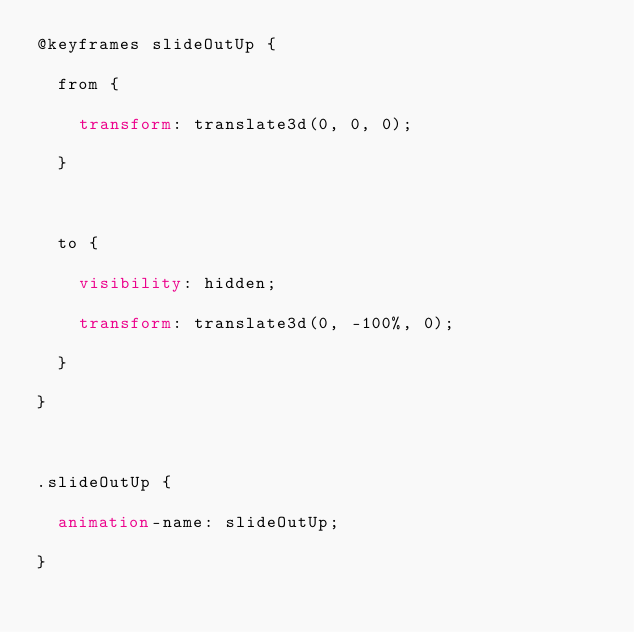Convert code to text. <code><loc_0><loc_0><loc_500><loc_500><_CSS_>@keyframes slideOutUp {
  from {
    transform: translate3d(0, 0, 0);
  }

  to {
    visibility: hidden;
    transform: translate3d(0, -100%, 0);
  }
}

.slideOutUp {
  animation-name: slideOutUp;
}
</code> 